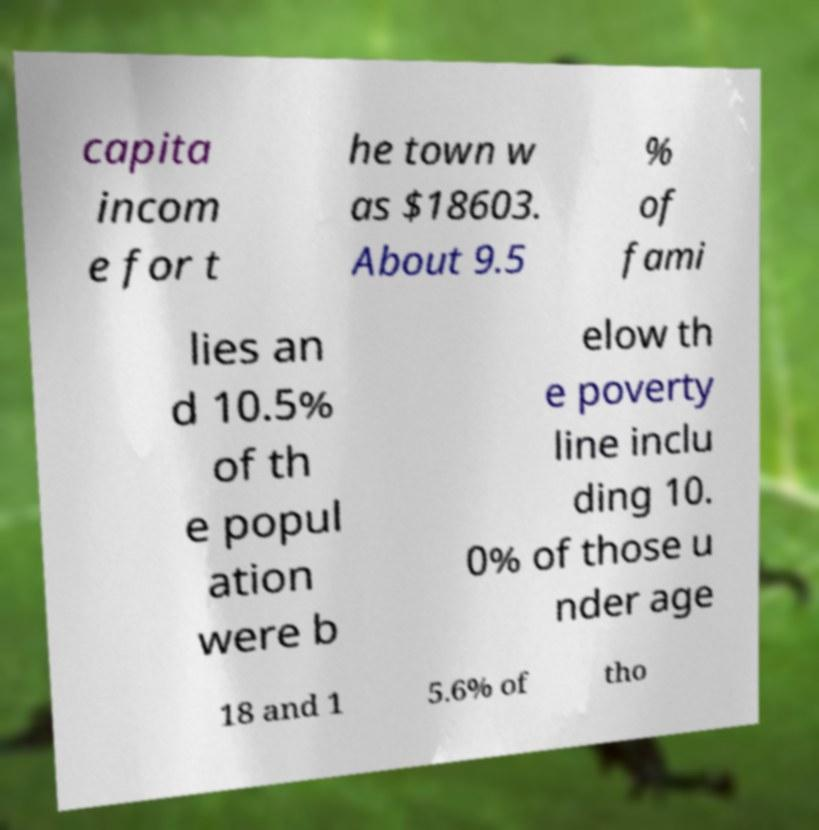Could you assist in decoding the text presented in this image and type it out clearly? capita incom e for t he town w as $18603. About 9.5 % of fami lies an d 10.5% of th e popul ation were b elow th e poverty line inclu ding 10. 0% of those u nder age 18 and 1 5.6% of tho 